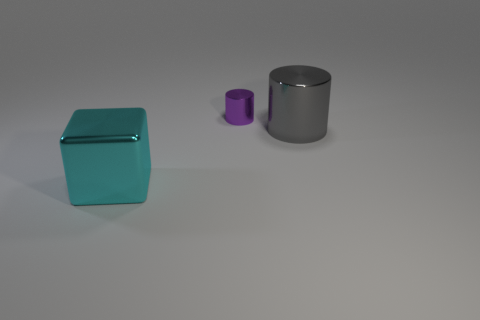How big is the thing that is both in front of the small purple metallic cylinder and behind the large cyan object?
Make the answer very short. Large. How many purple objects are there?
Your answer should be compact. 1. What number of cylinders are either matte objects or large metal things?
Ensure brevity in your answer.  1. How many tiny metallic cylinders are to the left of the big object behind the thing that is in front of the large gray metal thing?
Your response must be concise. 1. What is the color of the cylinder that is the same size as the cyan metallic cube?
Provide a short and direct response. Gray. How many other objects are the same color as the big metal cube?
Your answer should be very brief. 0. Are there more tiny purple shiny cylinders on the right side of the big gray object than large things?
Your answer should be very brief. No. Is the big cyan object made of the same material as the tiny purple cylinder?
Ensure brevity in your answer.  Yes. How many things are either objects that are on the right side of the cyan shiny object or tiny blue rubber balls?
Your response must be concise. 2. How many other things are the same size as the cyan block?
Keep it short and to the point. 1. 